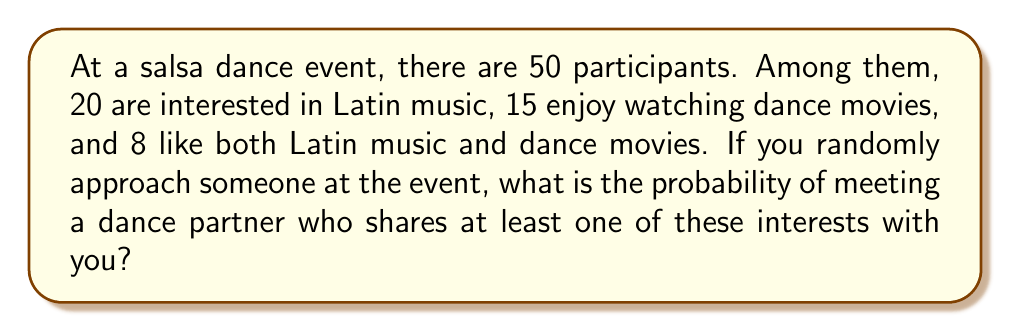Solve this math problem. Let's approach this problem using set theory and probability concepts:

1) Define our sets:
   Let A = set of people interested in Latin music
   Let B = set of people who enjoy watching dance movies

2) Given information:
   $|A| = 20$ (number of people interested in Latin music)
   $|B| = 15$ (number of people who enjoy watching dance movies)
   $|A \cap B| = 8$ (number of people who like both)
   Total participants = 50

3) To find the probability of meeting someone with at least one of these interests, we need to find the number of people in the union of A and B.

4) Using the inclusion-exclusion principle:
   $$|A \cup B| = |A| + |B| - |A \cap B|$$

5) Substituting the values:
   $$|A \cup B| = 20 + 15 - 8 = 27$$

6) Now, the probability of meeting someone with at least one of these interests is:
   $$P(A \cup B) = \frac{|A \cup B|}{\text{Total participants}} = \frac{27}{50}$$

7) Simplifying the fraction:
   $$\frac{27}{50} = 0.54$$

Therefore, the probability is 0.54 or 54%.
Answer: 0.54 or 54% 